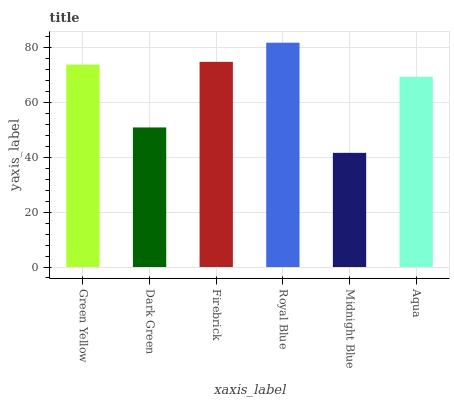Is Dark Green the minimum?
Answer yes or no. No. Is Dark Green the maximum?
Answer yes or no. No. Is Green Yellow greater than Dark Green?
Answer yes or no. Yes. Is Dark Green less than Green Yellow?
Answer yes or no. Yes. Is Dark Green greater than Green Yellow?
Answer yes or no. No. Is Green Yellow less than Dark Green?
Answer yes or no. No. Is Green Yellow the high median?
Answer yes or no. Yes. Is Aqua the low median?
Answer yes or no. Yes. Is Midnight Blue the high median?
Answer yes or no. No. Is Green Yellow the low median?
Answer yes or no. No. 